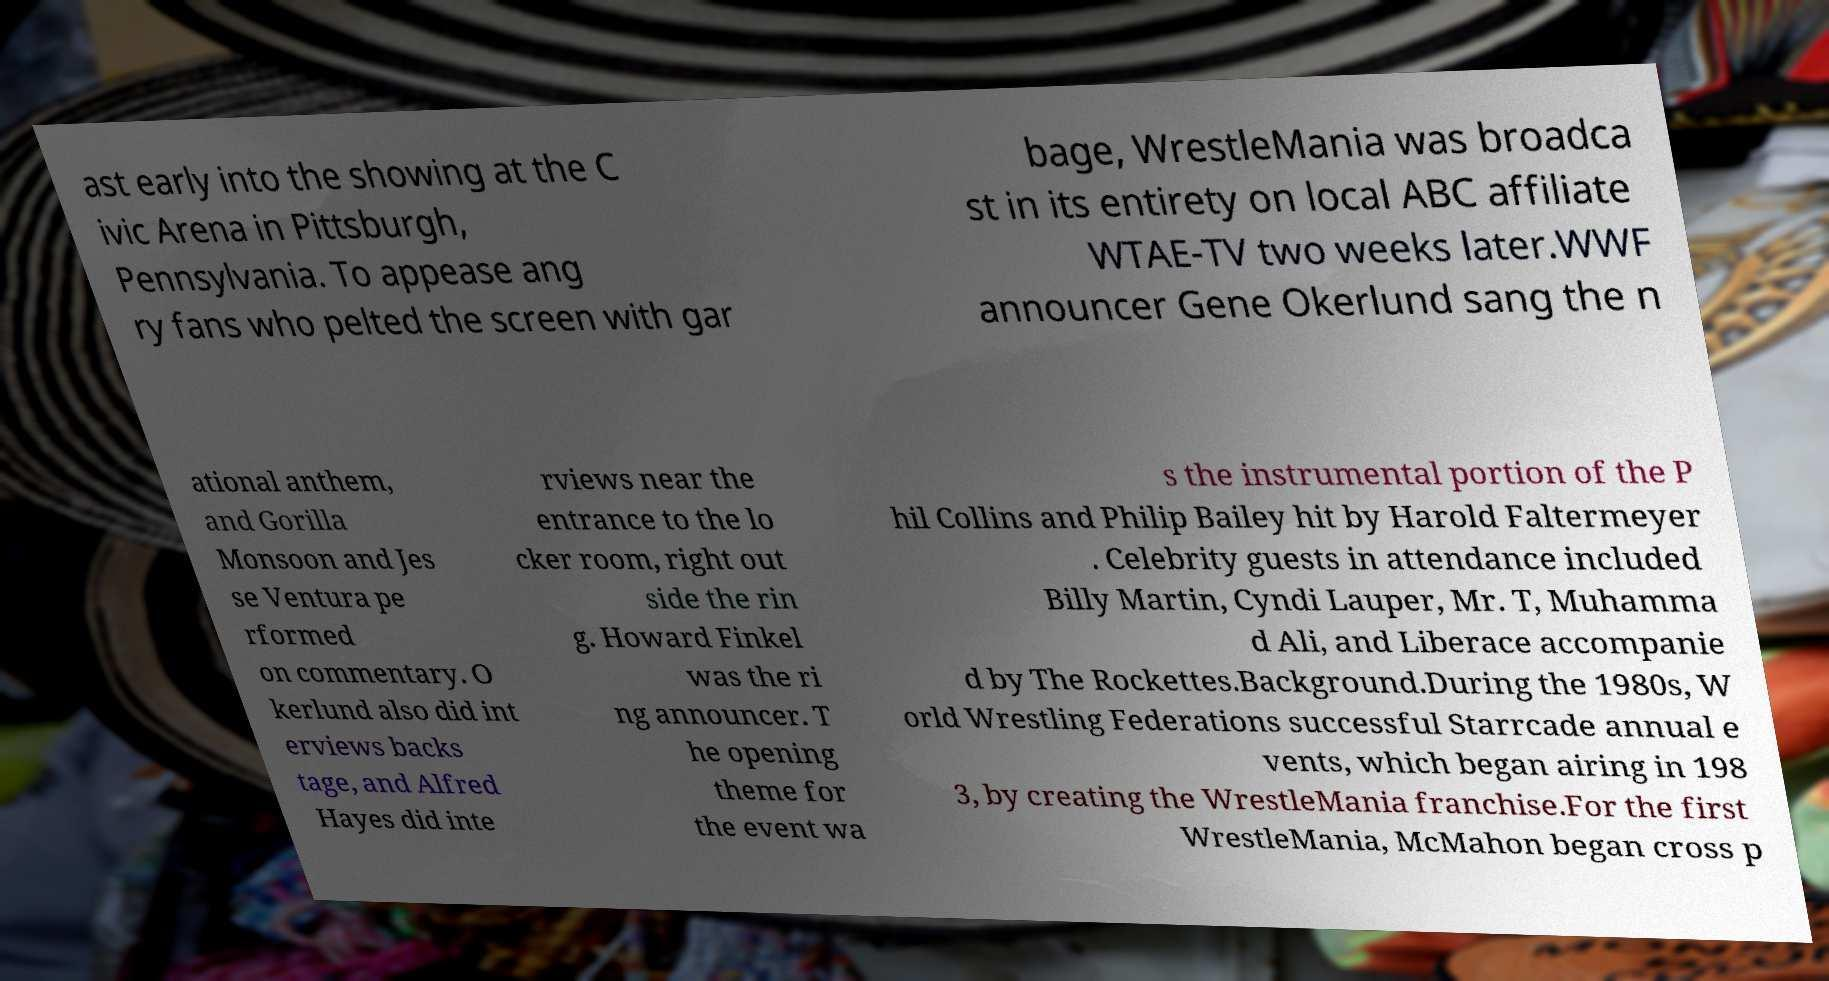There's text embedded in this image that I need extracted. Can you transcribe it verbatim? ast early into the showing at the C ivic Arena in Pittsburgh, Pennsylvania. To appease ang ry fans who pelted the screen with gar bage, WrestleMania was broadca st in its entirety on local ABC affiliate WTAE-TV two weeks later.WWF announcer Gene Okerlund sang the n ational anthem, and Gorilla Monsoon and Jes se Ventura pe rformed on commentary. O kerlund also did int erviews backs tage, and Alfred Hayes did inte rviews near the entrance to the lo cker room, right out side the rin g. Howard Finkel was the ri ng announcer. T he opening theme for the event wa s the instrumental portion of the P hil Collins and Philip Bailey hit by Harold Faltermeyer . Celebrity guests in attendance included Billy Martin, Cyndi Lauper, Mr. T, Muhamma d Ali, and Liberace accompanie d by The Rockettes.Background.During the 1980s, W orld Wrestling Federations successful Starrcade annual e vents, which began airing in 198 3, by creating the WrestleMania franchise.For the first WrestleMania, McMahon began cross p 